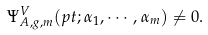<formula> <loc_0><loc_0><loc_500><loc_500>\Psi ^ { V } _ { A , g , m } ( p t ; \alpha _ { 1 } , \cdots , \alpha _ { m } ) \ne 0 .</formula> 